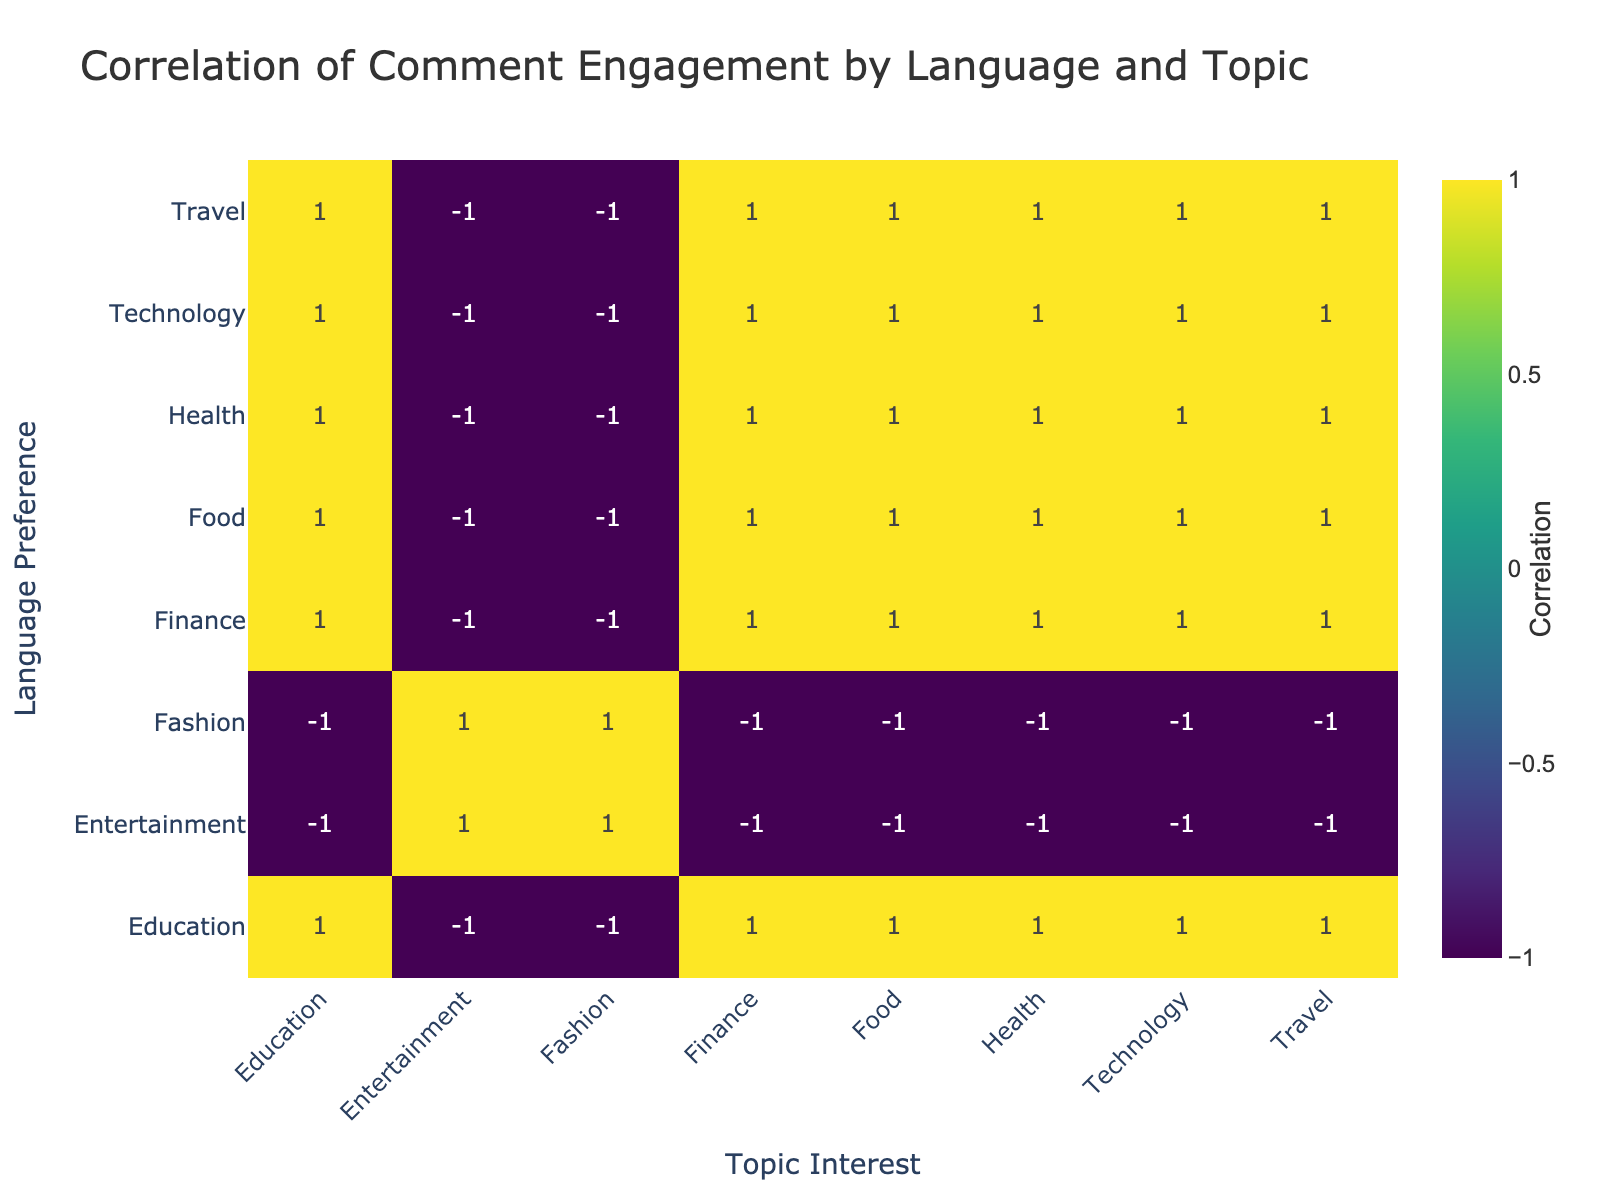What is the comment engagement for English speakers interested in Food? The table shows that the comment engagement for English speakers interested in Food is 70.
Answer: 70 What is the comment engagement for Spanish speakers interested in Technology? According to the table, the comment engagement for Spanish speakers interested in Technology is 20.
Answer: 20 Is the engagement for Spanish speakers higher in Travel than in Health? The comment engagement for Spanish speakers in Travel is 40, while in Health it is 25. Since 40 is greater than 25, the engagement in Travel is indeed higher.
Answer: Yes What is the average comment engagement for English speakers across all topics? The comment engagement for English speakers in each topic is: Technology (45), Travel (60), Fashion (30), Health (55), Food (70), Education (40), Finance (25), and Entertainment (50). Adding these gives a total of 375. There are 8 topics, so the average is 375 / 8 = 46.875.
Answer: 46.88 Do Spanish speakers show more engagement in Fashion than in Education? The engagement for Spanish speakers in Fashion is 50, while in Education it is 35. Since 50 is greater than 35, Spanish speakers show more engagement in Fashion.
Answer: Yes What is the combined comment engagement for English speakers in Technology, Health, and Food? The engagement for English speakers in Technology is 45, in Health is 55, and in Food is 70. Summing these values gives 45 + 55 + 70 = 170 for combined engagement.
Answer: 170 Which language preference has the highest comment engagement in Entertainment? The table indicates that English speakers have an engagement of 50 while Spanish speakers have 60. Since 60 is greater than 50, Spanish speakers have the highest engagement in Entertainment.
Answer: Spanish What is the difference in comment engagement between English and Spanish speakers for the Food topic? The engagement for English speakers in Food is 70, while for Spanish speakers, it is 30. The difference is 70 - 30 = 40.
Answer: 40 What is the total comment engagement for Spanish speakers across all topics? The engagement for Spanish speakers can be summed as follows: Technology (20), Travel (40), Fashion (50), Health (25), Food (30), Education (35), Finance (20), and Entertainment (60). This totals to 20 + 40 + 50 + 25 + 30 + 35 + 20 + 60 = 280.
Answer: 280 